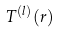Convert formula to latex. <formula><loc_0><loc_0><loc_500><loc_500>T ^ { ( l ) } ( r )</formula> 